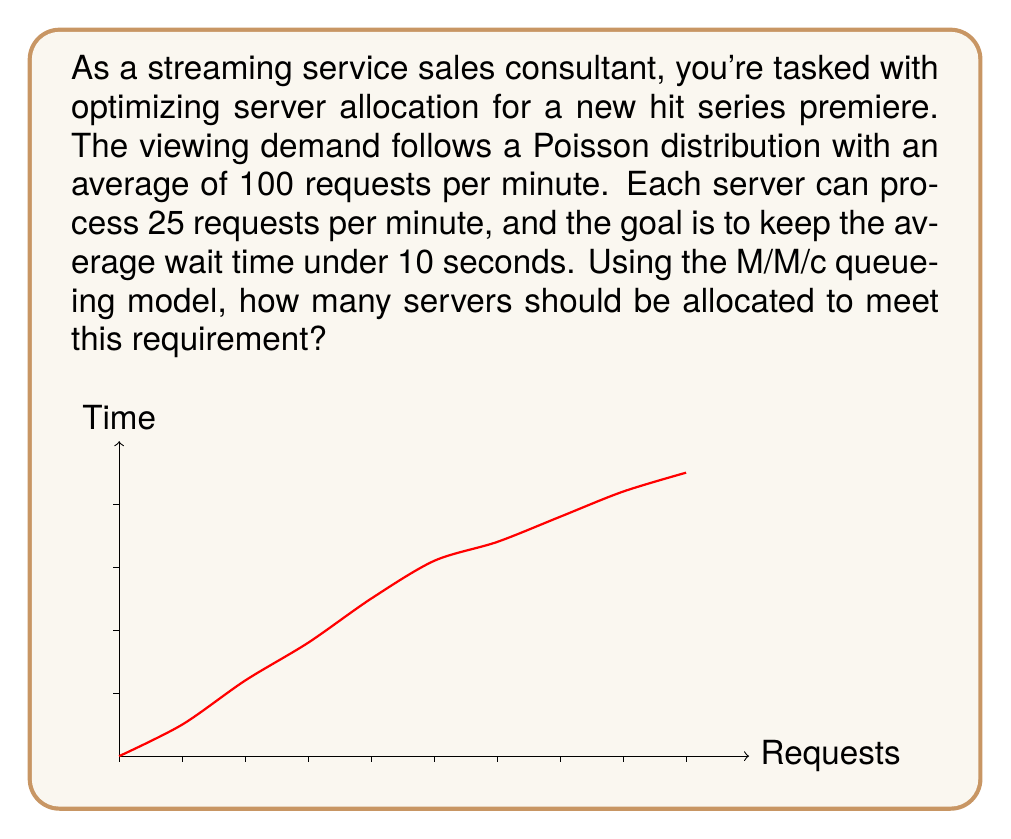Solve this math problem. To solve this problem, we'll use the M/M/c queueing model, where:
- M: Poisson arrival process
- M: Exponential service times
- c: Number of servers

Step 1: Calculate the system's arrival rate (λ) and service rate (μ).
λ = 100 requests/minute
μ = 25 requests/minute per server

Step 2: Calculate the utilization factor (ρ) for c servers:
$$ \rho = \frac{\lambda}{c\mu} $$

Step 3: Use the Erlang C formula to calculate the probability of waiting (P_w):
$$ P_w = \frac{(c\rho)^c}{c!(1-\rho)} \cdot \left[\sum_{n=0}^{c-1}\frac{(c\rho)^n}{n!} + \frac{(c\rho)^c}{c!(1-\rho)}\right]^{-1} $$

Step 4: Calculate the average waiting time (W_q):
$$ W_q = \frac{P_w}{c\mu - \lambda} $$

Step 5: Iterate through different values of c until W_q < 10 seconds (1/6 minute).

Using a computational tool or calculator:

For c = 5: ρ = 0.8, P_w ≈ 0.8674, W_q ≈ 0.2169 minutes (13.01 seconds)
For c = 6: ρ ≈ 0.6667, P_w ≈ 0.6031, W_q ≈ 0.0603 minutes (3.62 seconds)

Therefore, 6 servers are needed to keep the average wait time under 10 seconds.
Answer: 6 servers 